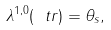Convert formula to latex. <formula><loc_0><loc_0><loc_500><loc_500>\lambda ^ { 1 , 0 } ( \ t r ) = \theta _ { s } ,</formula> 